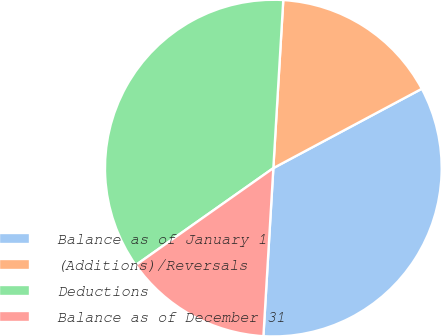Convert chart to OTSL. <chart><loc_0><loc_0><loc_500><loc_500><pie_chart><fcel>Balance as of January 1<fcel>(Additions)/Reversals<fcel>Deductions<fcel>Balance as of December 31<nl><fcel>33.75%<fcel>16.25%<fcel>35.71%<fcel>14.29%<nl></chart> 